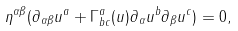Convert formula to latex. <formula><loc_0><loc_0><loc_500><loc_500>\eta ^ { \alpha \beta } ( \partial _ { \alpha \beta } u ^ { a } + \Gamma _ { b c } ^ { a } ( u ) \partial _ { \alpha } u ^ { b } \partial _ { \beta } u ^ { c } ) = 0 ,</formula> 